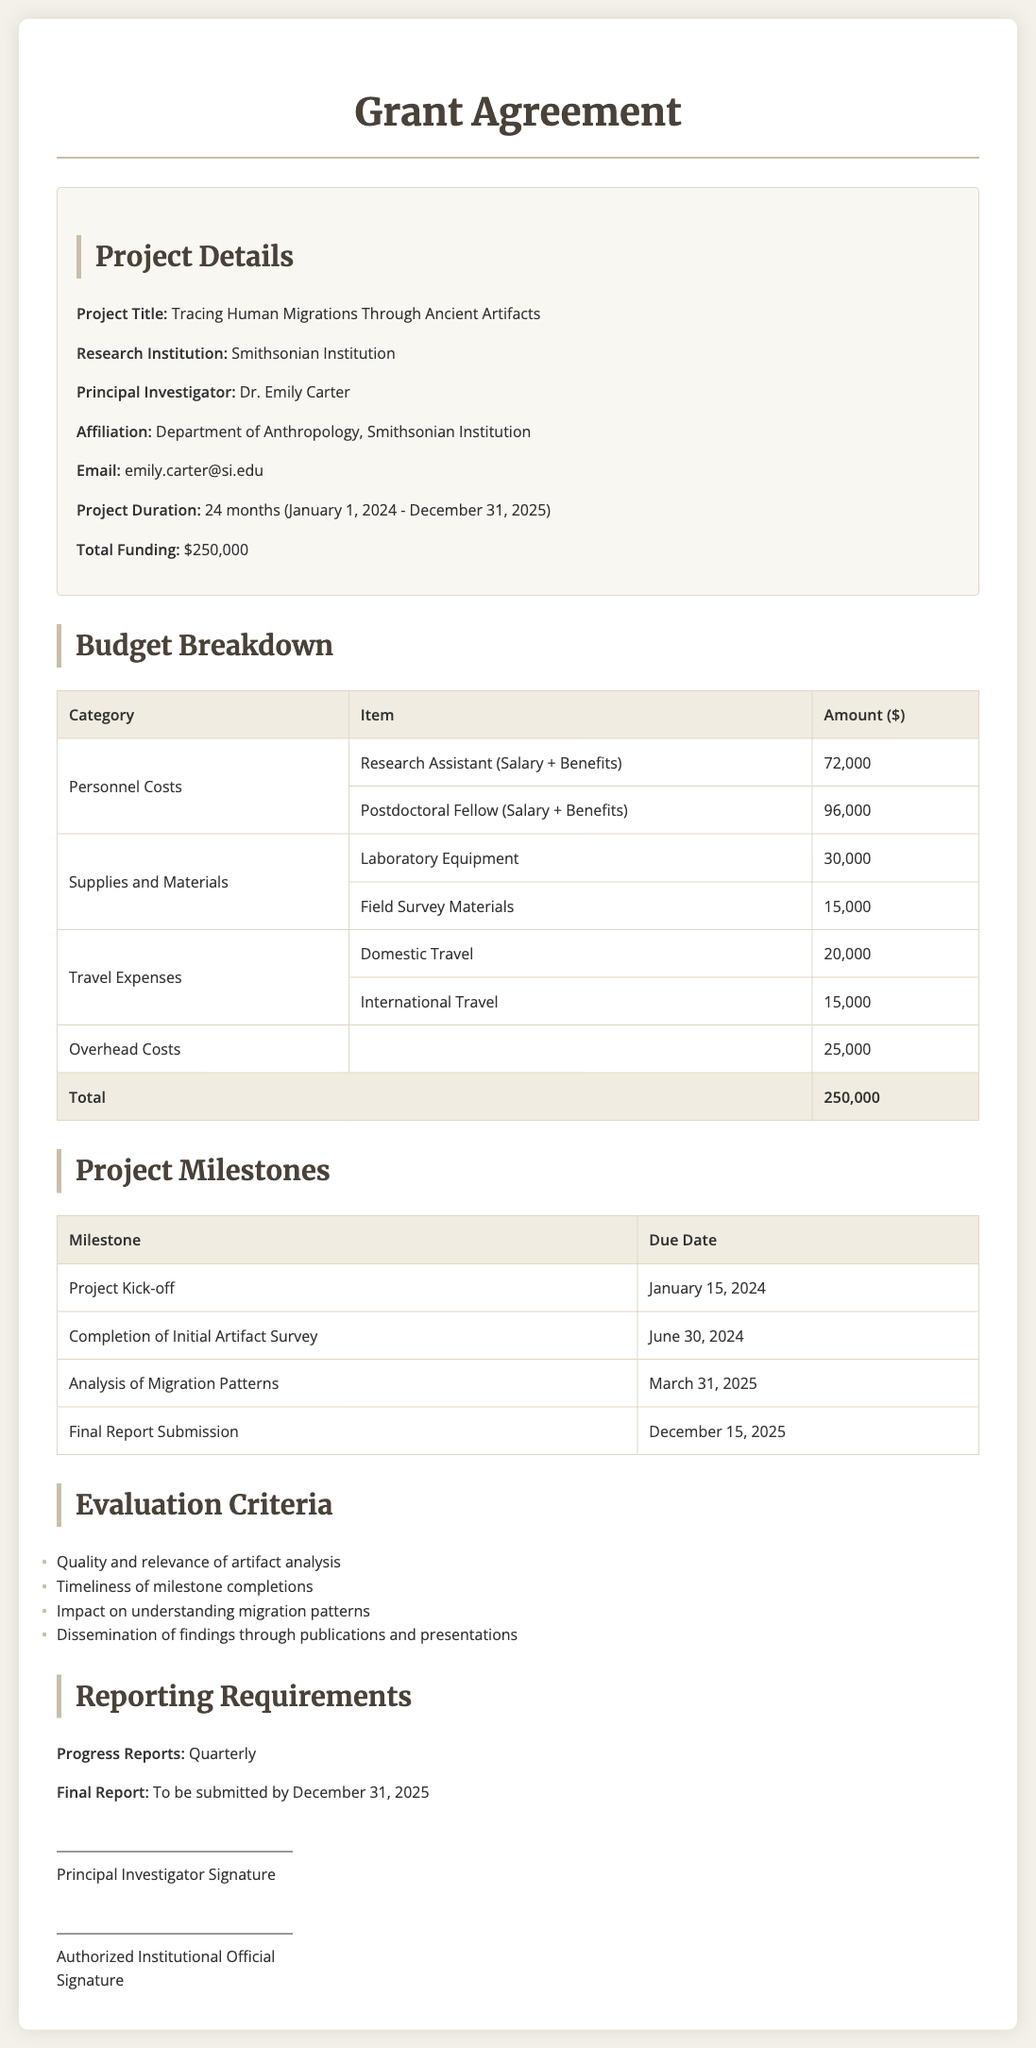what is the project title? The project title is specifically mentioned in the document, which is "Tracing Human Migrations Through Ancient Artifacts".
Answer: Tracing Human Migrations Through Ancient Artifacts who is the principal investigator? The principal investigator's name is provided in the project details section of the document.
Answer: Dr. Emily Carter what is the total funding amount? The total funding amount is stated in the project details section.
Answer: $250,000 when is the project kick-off date? The project kick-off date is listed under the project milestones section in the document.
Answer: January 15, 2024 what is the due date for the final report submission? The due date for the final report submission is specified later in the document.
Answer: December 31, 2025 how many months is the project duration? The project duration, as indicated in the document, is 24 months.
Answer: 24 months what is the amount allocated for travel expenses? The budget breakdown specifies the total amount allocated for travel expenses.
Answer: $35,000 which institution is the research project affiliated with? The research institution is explicitly mentioned in the project details.
Answer: Smithsonian Institution 